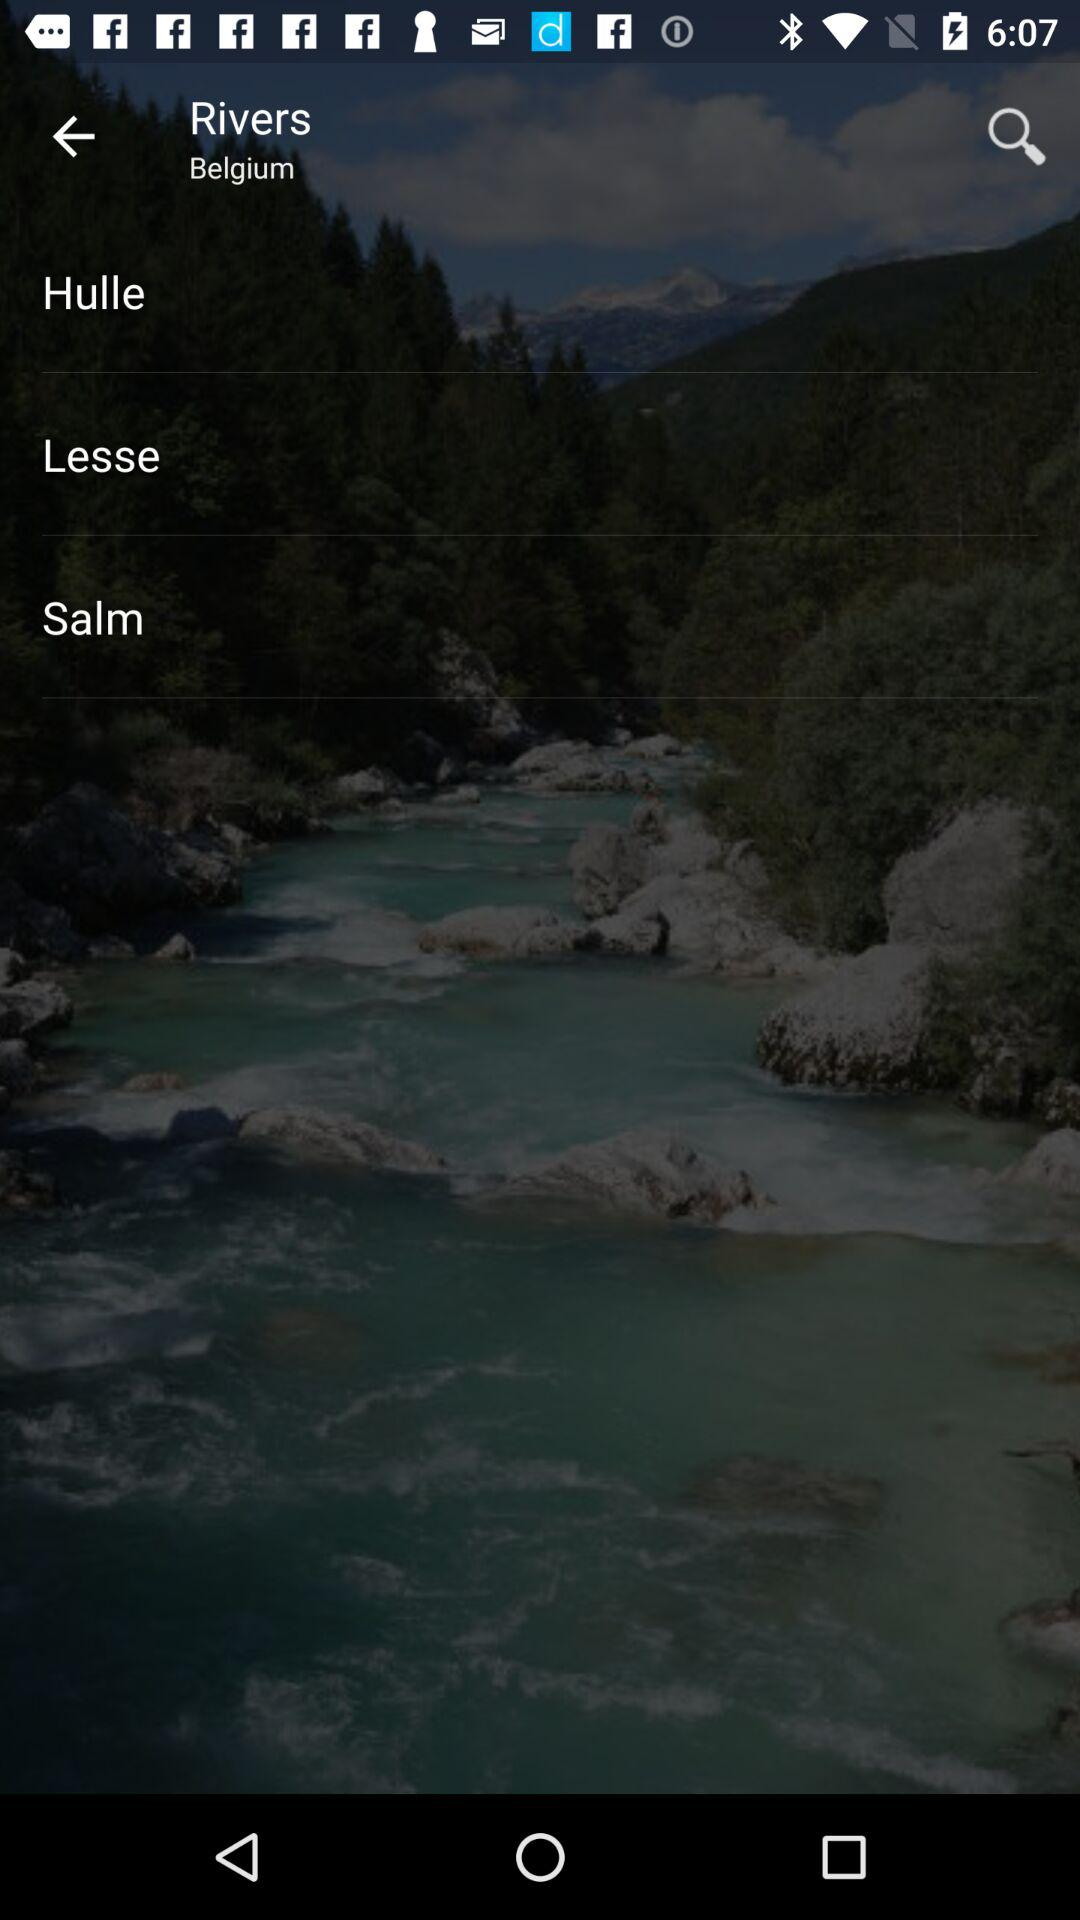What is the location of rivers? The location is Belgium. 